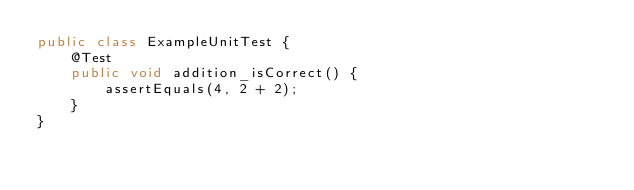<code> <loc_0><loc_0><loc_500><loc_500><_Java_>public class ExampleUnitTest {
    @Test
    public void addition_isCorrect() {
        assertEquals(4, 2 + 2);
    }
}</code> 